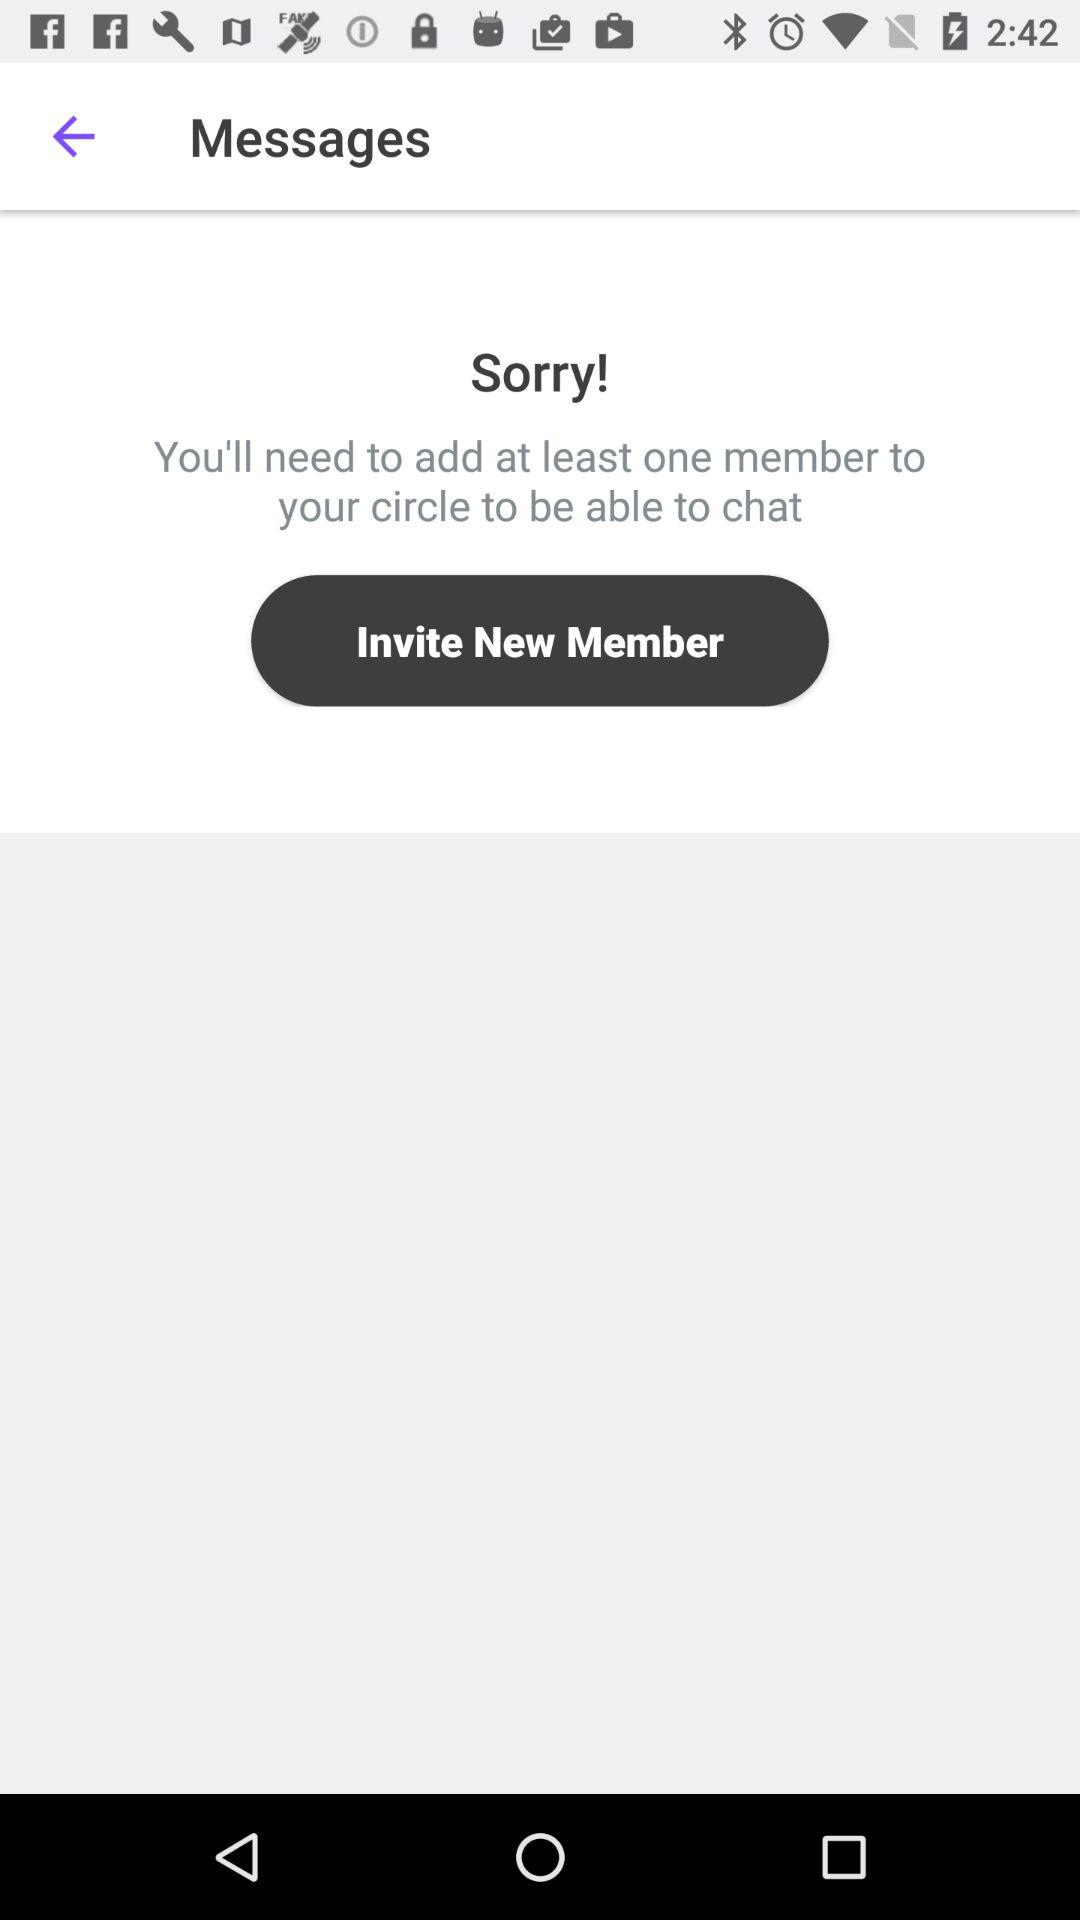How many members do I need to add to my circle to be able to chat?
Answer the question using a single word or phrase. At least one 